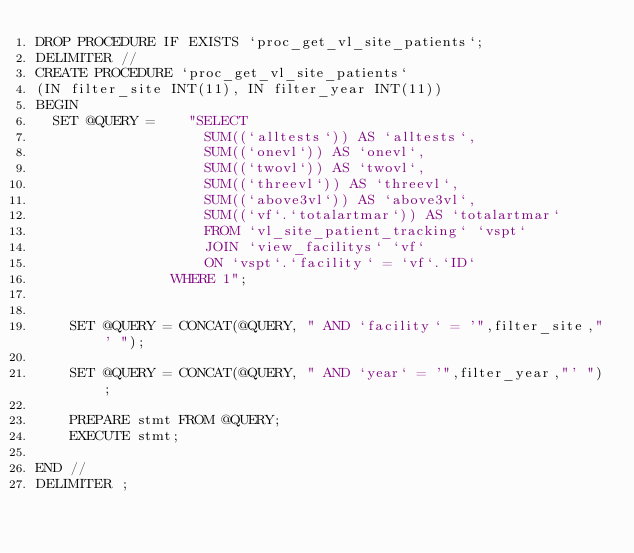Convert code to text. <code><loc_0><loc_0><loc_500><loc_500><_SQL_>DROP PROCEDURE IF EXISTS `proc_get_vl_site_patients`;
DELIMITER //
CREATE PROCEDURE `proc_get_vl_site_patients`
(IN filter_site INT(11), IN filter_year INT(11))
BEGIN
  SET @QUERY =    "SELECT  
                    SUM((`alltests`)) AS `alltests`,
                    SUM((`onevl`)) AS `onevl`,
                    SUM((`twovl`)) AS `twovl`,
                    SUM((`threevl`)) AS `threevl`,
                    SUM((`above3vl`)) AS `above3vl`,
                    SUM((`vf`.`totalartmar`)) AS `totalartmar`
                    FROM `vl_site_patient_tracking` `vspt`
                    JOIN `view_facilitys` `vf` 
                    ON `vspt`.`facility` = `vf`.`ID`
                WHERE 1";

   
    SET @QUERY = CONCAT(@QUERY, " AND `facility` = '",filter_site,"' ");

    SET @QUERY = CONCAT(@QUERY, " AND `year` = '",filter_year,"' ");

    PREPARE stmt FROM @QUERY;
    EXECUTE stmt;
    
END //
DELIMITER ;

</code> 